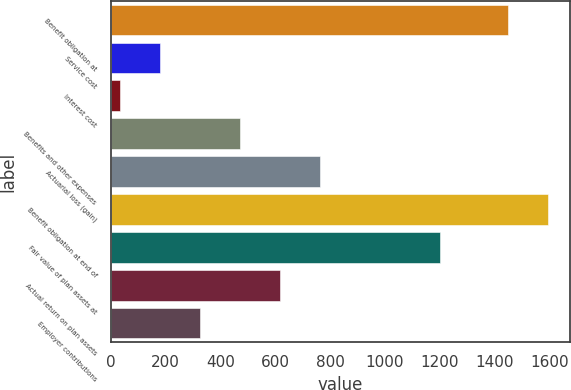Convert chart to OTSL. <chart><loc_0><loc_0><loc_500><loc_500><bar_chart><fcel>Benefit obligation at<fcel>Service cost<fcel>Interest cost<fcel>Benefits and other expenses<fcel>Actuarial loss (gain)<fcel>Benefit obligation at end of<fcel>Fair value of plan assets at<fcel>Actual return on plan assets<fcel>Employer contributions<nl><fcel>1449.3<fcel>178.82<fcel>32.8<fcel>470.86<fcel>762.9<fcel>1595.32<fcel>1200.96<fcel>616.88<fcel>324.84<nl></chart> 